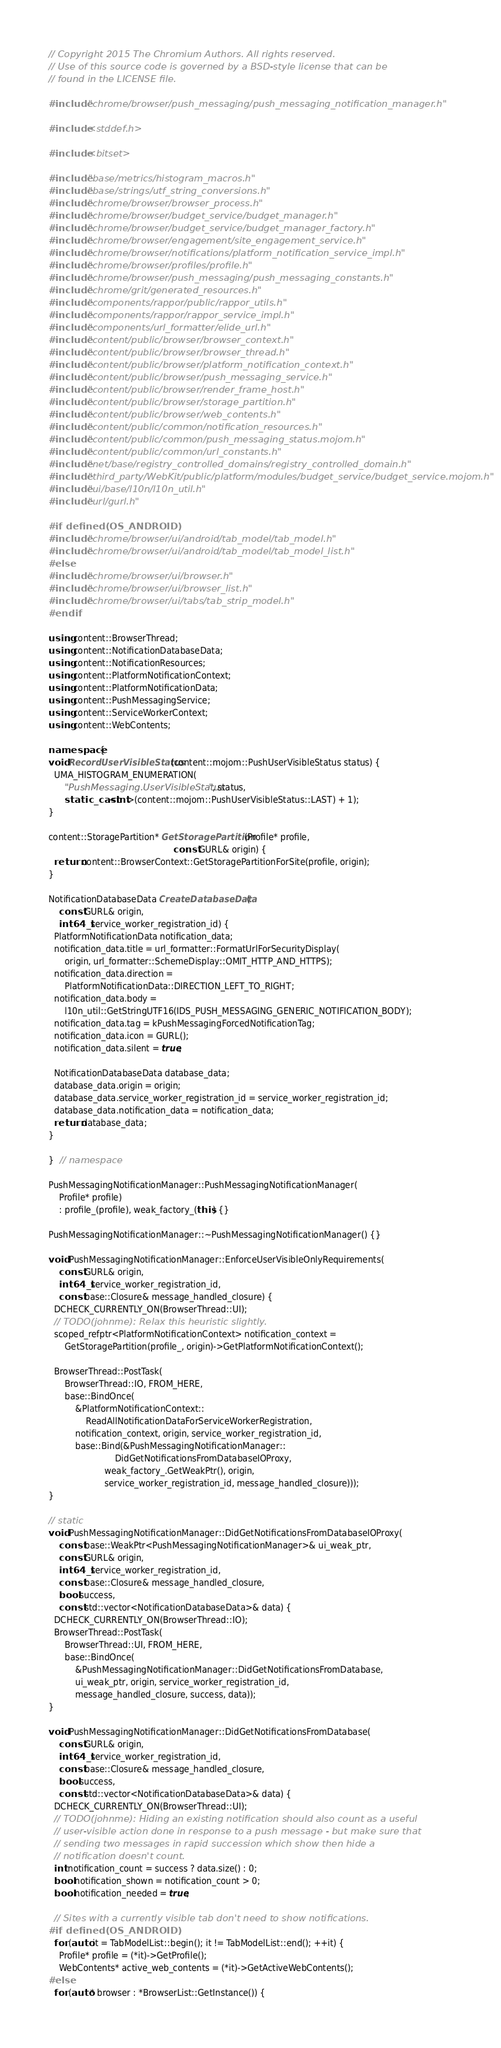<code> <loc_0><loc_0><loc_500><loc_500><_C++_>// Copyright 2015 The Chromium Authors. All rights reserved.
// Use of this source code is governed by a BSD-style license that can be
// found in the LICENSE file.

#include "chrome/browser/push_messaging/push_messaging_notification_manager.h"

#include <stddef.h>

#include <bitset>

#include "base/metrics/histogram_macros.h"
#include "base/strings/utf_string_conversions.h"
#include "chrome/browser/browser_process.h"
#include "chrome/browser/budget_service/budget_manager.h"
#include "chrome/browser/budget_service/budget_manager_factory.h"
#include "chrome/browser/engagement/site_engagement_service.h"
#include "chrome/browser/notifications/platform_notification_service_impl.h"
#include "chrome/browser/profiles/profile.h"
#include "chrome/browser/push_messaging/push_messaging_constants.h"
#include "chrome/grit/generated_resources.h"
#include "components/rappor/public/rappor_utils.h"
#include "components/rappor/rappor_service_impl.h"
#include "components/url_formatter/elide_url.h"
#include "content/public/browser/browser_context.h"
#include "content/public/browser/browser_thread.h"
#include "content/public/browser/platform_notification_context.h"
#include "content/public/browser/push_messaging_service.h"
#include "content/public/browser/render_frame_host.h"
#include "content/public/browser/storage_partition.h"
#include "content/public/browser/web_contents.h"
#include "content/public/common/notification_resources.h"
#include "content/public/common/push_messaging_status.mojom.h"
#include "content/public/common/url_constants.h"
#include "net/base/registry_controlled_domains/registry_controlled_domain.h"
#include "third_party/WebKit/public/platform/modules/budget_service/budget_service.mojom.h"
#include "ui/base/l10n/l10n_util.h"
#include "url/gurl.h"

#if defined(OS_ANDROID)
#include "chrome/browser/ui/android/tab_model/tab_model.h"
#include "chrome/browser/ui/android/tab_model/tab_model_list.h"
#else
#include "chrome/browser/ui/browser.h"
#include "chrome/browser/ui/browser_list.h"
#include "chrome/browser/ui/tabs/tab_strip_model.h"
#endif

using content::BrowserThread;
using content::NotificationDatabaseData;
using content::NotificationResources;
using content::PlatformNotificationContext;
using content::PlatformNotificationData;
using content::PushMessagingService;
using content::ServiceWorkerContext;
using content::WebContents;

namespace {
void RecordUserVisibleStatus(content::mojom::PushUserVisibleStatus status) {
  UMA_HISTOGRAM_ENUMERATION(
      "PushMessaging.UserVisibleStatus", status,
      static_cast<int>(content::mojom::PushUserVisibleStatus::LAST) + 1);
}

content::StoragePartition* GetStoragePartition(Profile* profile,
                                               const GURL& origin) {
  return content::BrowserContext::GetStoragePartitionForSite(profile, origin);
}

NotificationDatabaseData CreateDatabaseData(
    const GURL& origin,
    int64_t service_worker_registration_id) {
  PlatformNotificationData notification_data;
  notification_data.title = url_formatter::FormatUrlForSecurityDisplay(
      origin, url_formatter::SchemeDisplay::OMIT_HTTP_AND_HTTPS);
  notification_data.direction =
      PlatformNotificationData::DIRECTION_LEFT_TO_RIGHT;
  notification_data.body =
      l10n_util::GetStringUTF16(IDS_PUSH_MESSAGING_GENERIC_NOTIFICATION_BODY);
  notification_data.tag = kPushMessagingForcedNotificationTag;
  notification_data.icon = GURL();
  notification_data.silent = true;

  NotificationDatabaseData database_data;
  database_data.origin = origin;
  database_data.service_worker_registration_id = service_worker_registration_id;
  database_data.notification_data = notification_data;
  return database_data;
}

}  // namespace

PushMessagingNotificationManager::PushMessagingNotificationManager(
    Profile* profile)
    : profile_(profile), weak_factory_(this) {}

PushMessagingNotificationManager::~PushMessagingNotificationManager() {}

void PushMessagingNotificationManager::EnforceUserVisibleOnlyRequirements(
    const GURL& origin,
    int64_t service_worker_registration_id,
    const base::Closure& message_handled_closure) {
  DCHECK_CURRENTLY_ON(BrowserThread::UI);
  // TODO(johnme): Relax this heuristic slightly.
  scoped_refptr<PlatformNotificationContext> notification_context =
      GetStoragePartition(profile_, origin)->GetPlatformNotificationContext();

  BrowserThread::PostTask(
      BrowserThread::IO, FROM_HERE,
      base::BindOnce(
          &PlatformNotificationContext::
              ReadAllNotificationDataForServiceWorkerRegistration,
          notification_context, origin, service_worker_registration_id,
          base::Bind(&PushMessagingNotificationManager::
                         DidGetNotificationsFromDatabaseIOProxy,
                     weak_factory_.GetWeakPtr(), origin,
                     service_worker_registration_id, message_handled_closure)));
}

// static
void PushMessagingNotificationManager::DidGetNotificationsFromDatabaseIOProxy(
    const base::WeakPtr<PushMessagingNotificationManager>& ui_weak_ptr,
    const GURL& origin,
    int64_t service_worker_registration_id,
    const base::Closure& message_handled_closure,
    bool success,
    const std::vector<NotificationDatabaseData>& data) {
  DCHECK_CURRENTLY_ON(BrowserThread::IO);
  BrowserThread::PostTask(
      BrowserThread::UI, FROM_HERE,
      base::BindOnce(
          &PushMessagingNotificationManager::DidGetNotificationsFromDatabase,
          ui_weak_ptr, origin, service_worker_registration_id,
          message_handled_closure, success, data));
}

void PushMessagingNotificationManager::DidGetNotificationsFromDatabase(
    const GURL& origin,
    int64_t service_worker_registration_id,
    const base::Closure& message_handled_closure,
    bool success,
    const std::vector<NotificationDatabaseData>& data) {
  DCHECK_CURRENTLY_ON(BrowserThread::UI);
  // TODO(johnme): Hiding an existing notification should also count as a useful
  // user-visible action done in response to a push message - but make sure that
  // sending two messages in rapid succession which show then hide a
  // notification doesn't count.
  int notification_count = success ? data.size() : 0;
  bool notification_shown = notification_count > 0;
  bool notification_needed = true;

  // Sites with a currently visible tab don't need to show notifications.
#if defined(OS_ANDROID)
  for (auto it = TabModelList::begin(); it != TabModelList::end(); ++it) {
    Profile* profile = (*it)->GetProfile();
    WebContents* active_web_contents = (*it)->GetActiveWebContents();
#else
  for (auto* browser : *BrowserList::GetInstance()) {</code> 